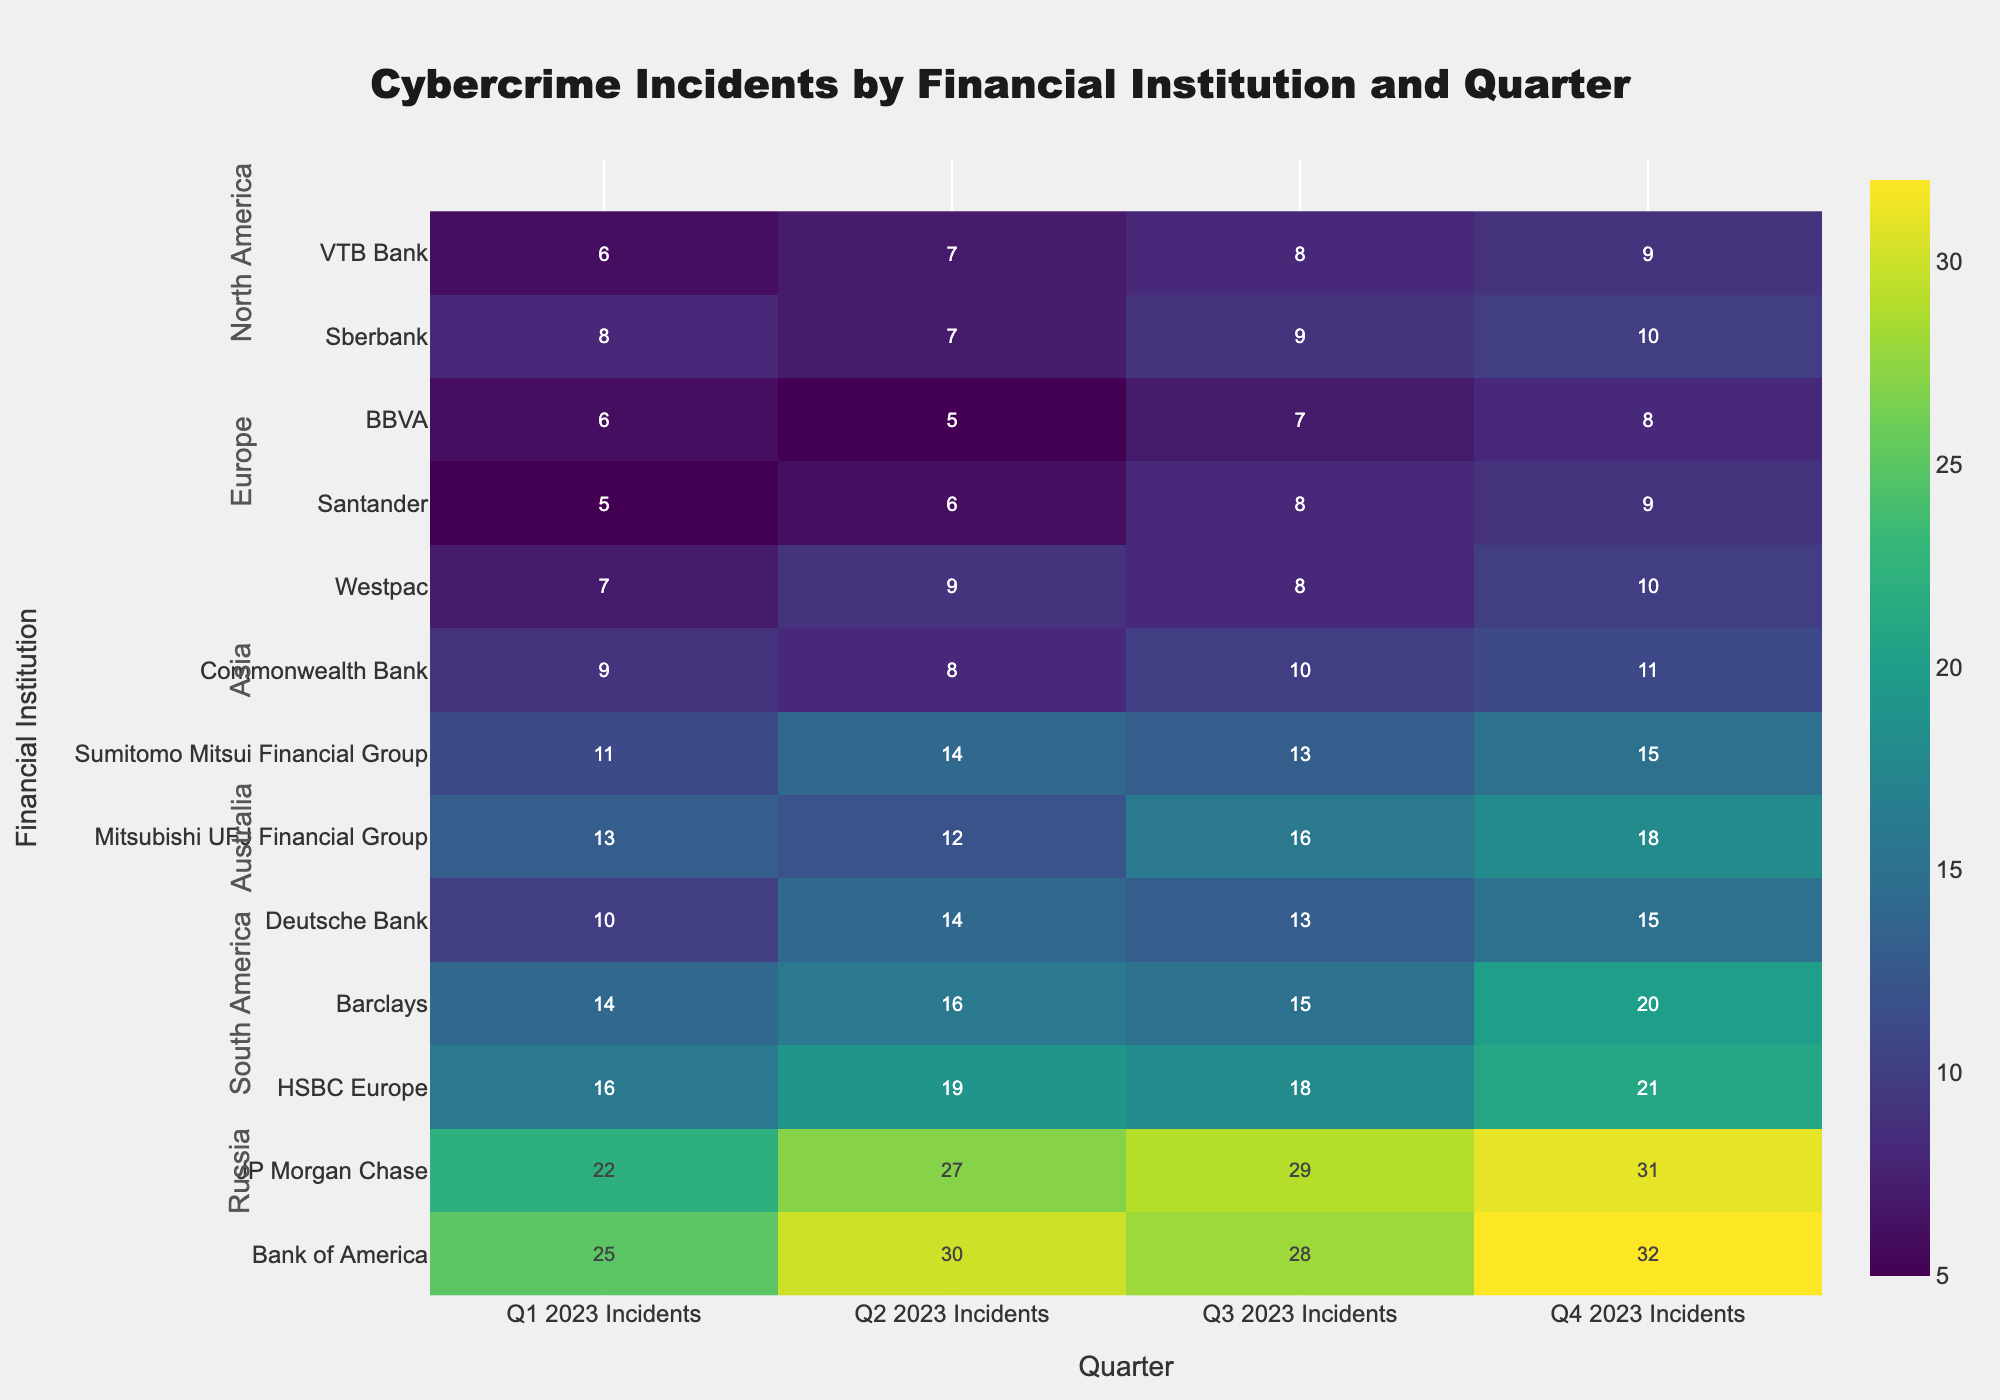What's the title of the heatmap? The title is generally placed at the top center of the heatmap. By looking at this position, we can see it reads "Cybercrime Incidents by Financial Institution and Quarter."
Answer: Cybercrime Incidents by Financial Institution and Quarter Which financial institution had the highest incidents in Q4 2023? To determine the institution with the highest incidents in Q4 2023, scan the Q4 column and identify the highest number, which is 32 for Bank of America.
Answer: Bank of America How many total cybercrime incidents were reported by JP Morgan Chase in 2023? Sum the incidents across all quarters for JP Morgan Chase: 22 (Q1) + 27 (Q2) + 29 (Q3) + 31 (Q4) = 109.
Answer: 109 Which geographical zone had the least incidents in Q2 2023? Scan the zones in the Q2 column and identify the geographical zone with the lowest number. South America has the lowest incidents with 5 and 6 incidents for BBVA and Santander respectively.
Answer: South America What was the average number of incidents for European banks in Q3 2023? European banks in Q3 2023 have incidents of 18 (HSBC Europe), 15 (Barclays), and 13 (Deutsche Bank). The sum is 18 + 15 + 13 = 46. There are 3 banks, so the average is 46/3 = 15.33.
Answer: 15.33 Which geographical zone shows an increasing trend each quarter for Bank of America and JP Morgan Chase? Observing the incident counts for Bank of America and JP Morgan Chase each quarter: Bank of America has 25, 30, 28, 32 and JP Morgan Chase has 22, 27, 29, 31. Both are in North America and show an increasing trend overall.
Answer: North America Which bank had the lowest number of incidents in Q1 2023, and how many were reported? Look at the Q1 2023 column and find the smallest number, which is for Westpac with 7 incidents.
Answer: Westpac, 7 Which bank in Asia had incidents continuously increase across all quarters? For Asian banks, observe the incident counts: Mitsubishi UFJ Financial Group has a sequence of 13, 12, 16, 18; Sumitomo Mitsui Financial Group has 11, 14, 13, 15. Mitsubishi UFJ Financial Group shows an increasing trend.
Answer: Mitsubishi UFJ Financial Group What is the total number of cybercrime incidents across all banks in Europe in Q4 2023? Sum the incidents reported by European banks in Q4 2023: 21 (HSBC Europe) + 20 (Barclays) + 15 (Deutsche Bank) = 56.
Answer: 56 How did cybercrime incidents change from Q1 2023 to Q4 2023 for Santander? For Santander, the incident counts are 5 in Q1 and 9 in Q4, indicating an increase of 4 incidents.
Answer: Increased by 4 